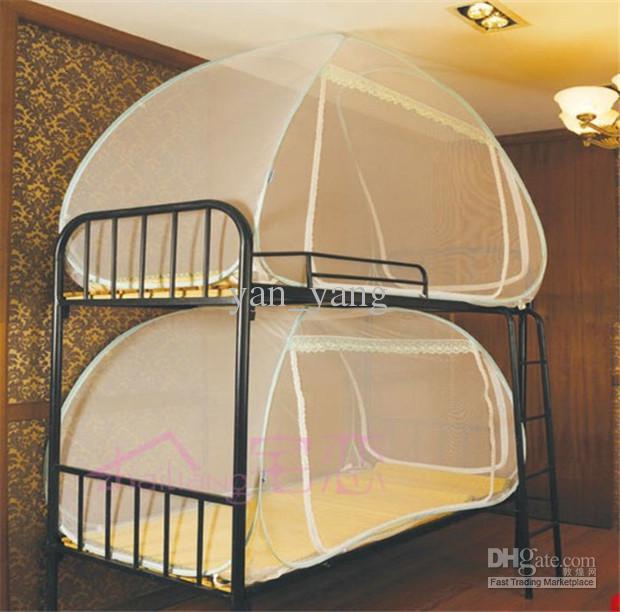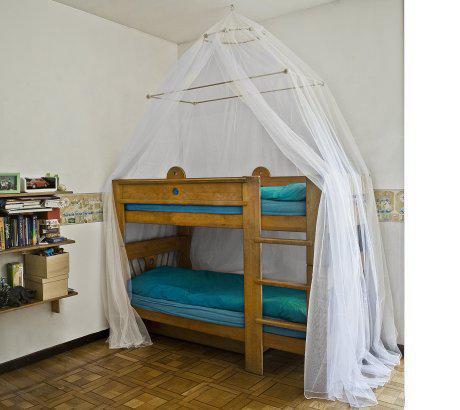The first image is the image on the left, the second image is the image on the right. For the images shown, is this caption "An image shows a ceiling-suspended tent-shaped gauze canopy over bunk beds." true? Answer yes or no. Yes. 